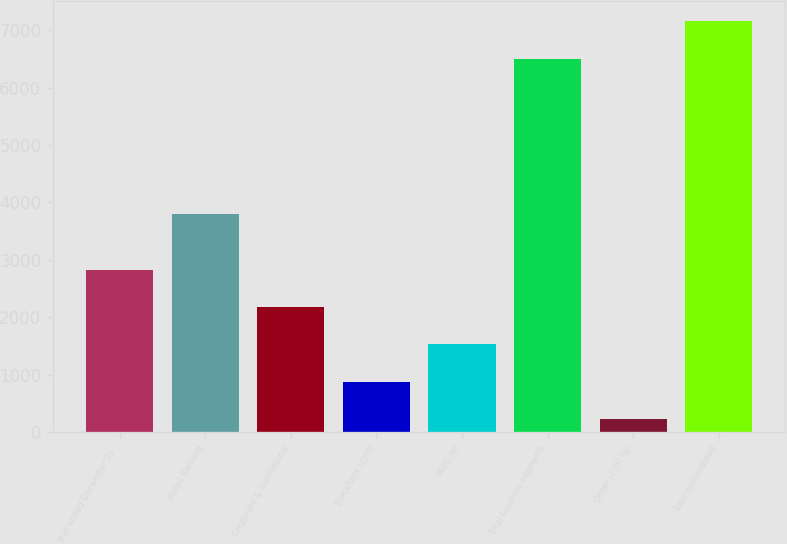<chart> <loc_0><loc_0><loc_500><loc_500><bar_chart><fcel>Year ended December 31 -<fcel>Retail Banking<fcel>Corporate & Institutional<fcel>BlackRock (c)(d)<fcel>PFPC (e)<fcel>Total business segments<fcel>Other (c )(f) (g)<fcel>Total consolidated<nl><fcel>2827.2<fcel>3801<fcel>2176.4<fcel>874.8<fcel>1525.6<fcel>6508<fcel>224<fcel>7158.8<nl></chart> 